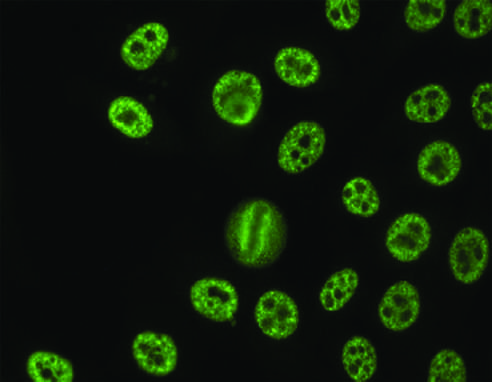s the wall of the artery seen with antibodies against various nuclear antigens, including sm and rnps?
Answer the question using a single word or phrase. No 